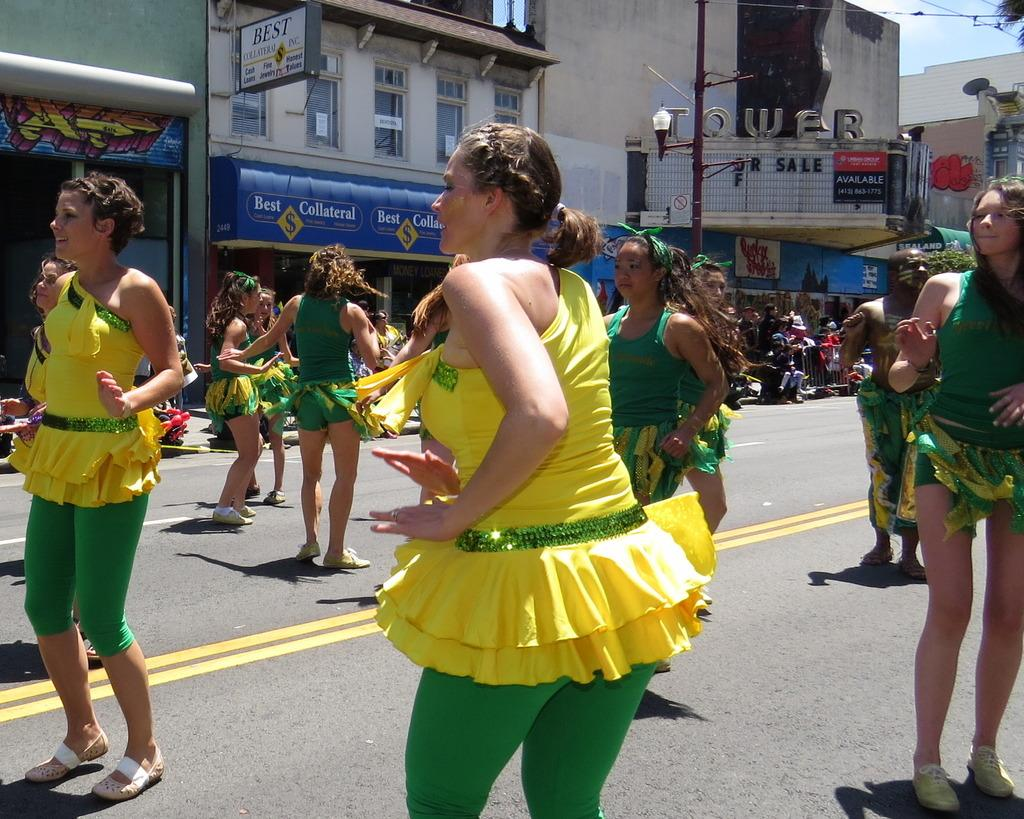Who or what can be seen in the image? There are people in the image. What type of structures are visible in the image? There are buildings in the image. What additional objects can be seen in the image? Banners and a street lamp are present in the image. What can be seen in the background of the image? The sky is visible in the image. What type of bird is flying over the range in the image? There is no bird or range present in the image. 